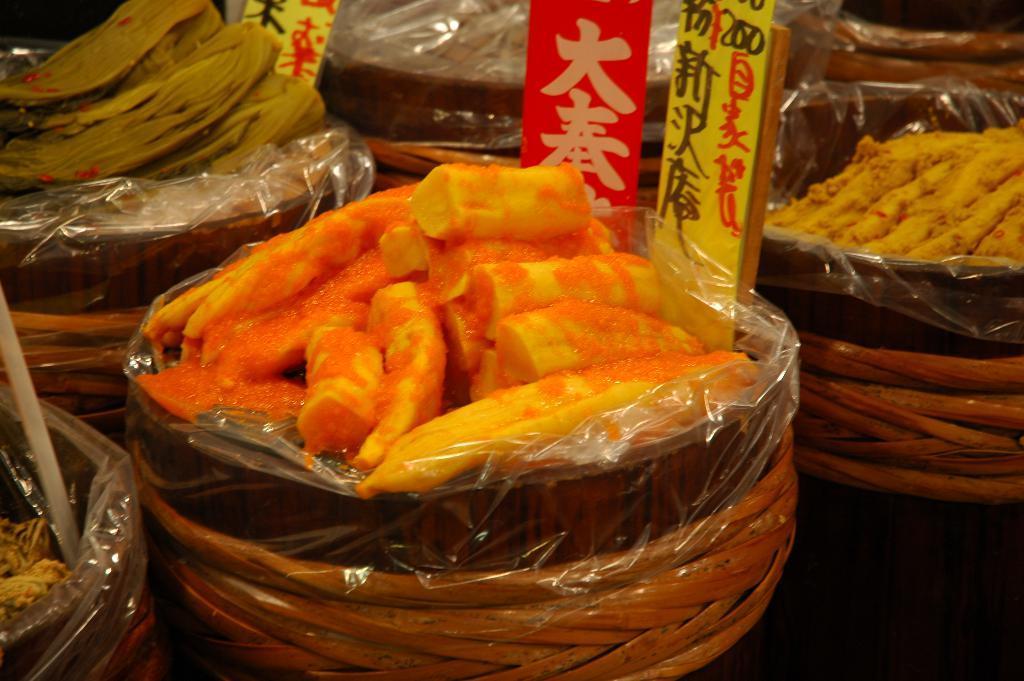In one or two sentences, can you explain what this image depicts? In this image there are a few food items in the bowls and few labels. 